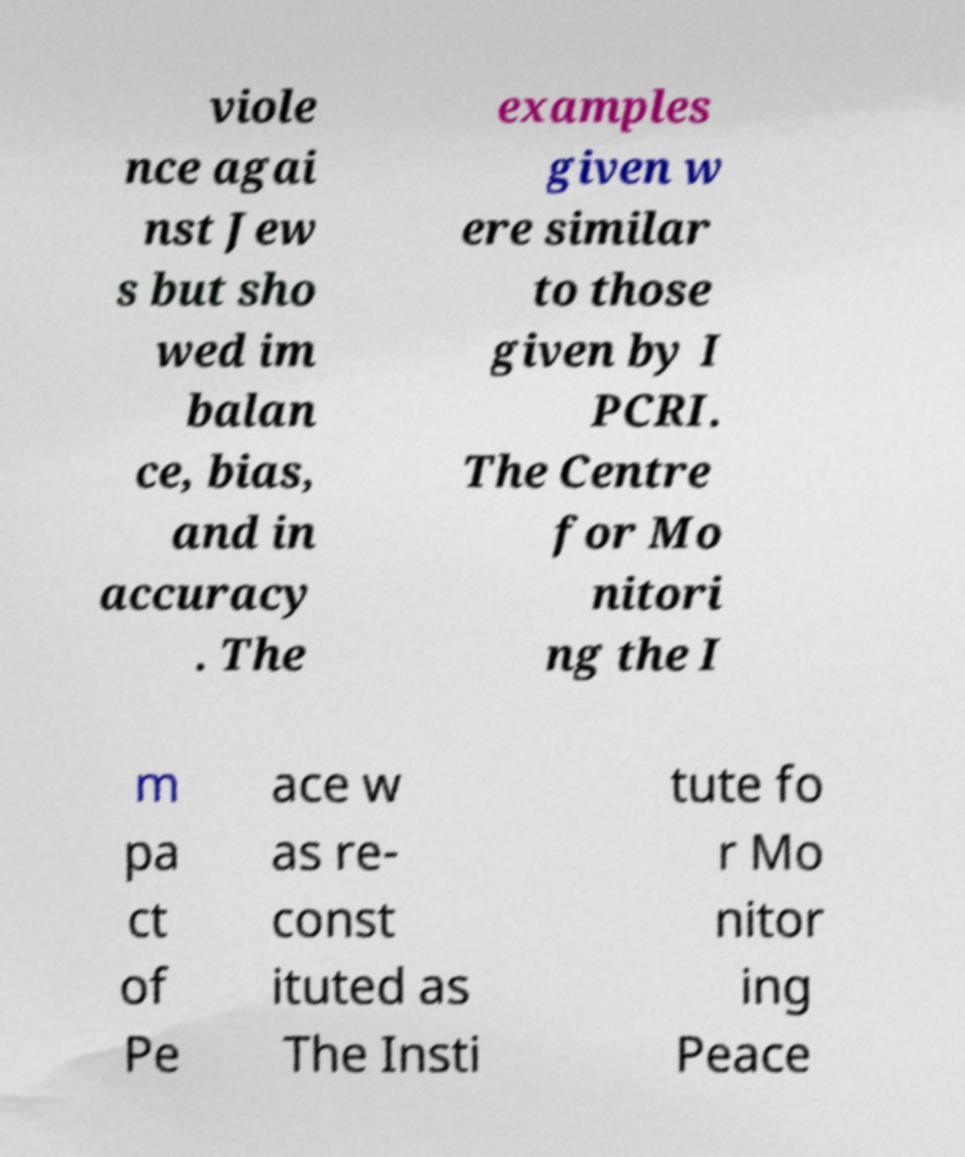For documentation purposes, I need the text within this image transcribed. Could you provide that? viole nce agai nst Jew s but sho wed im balan ce, bias, and in accuracy . The examples given w ere similar to those given by I PCRI. The Centre for Mo nitori ng the I m pa ct of Pe ace w as re- const ituted as The Insti tute fo r Mo nitor ing Peace 